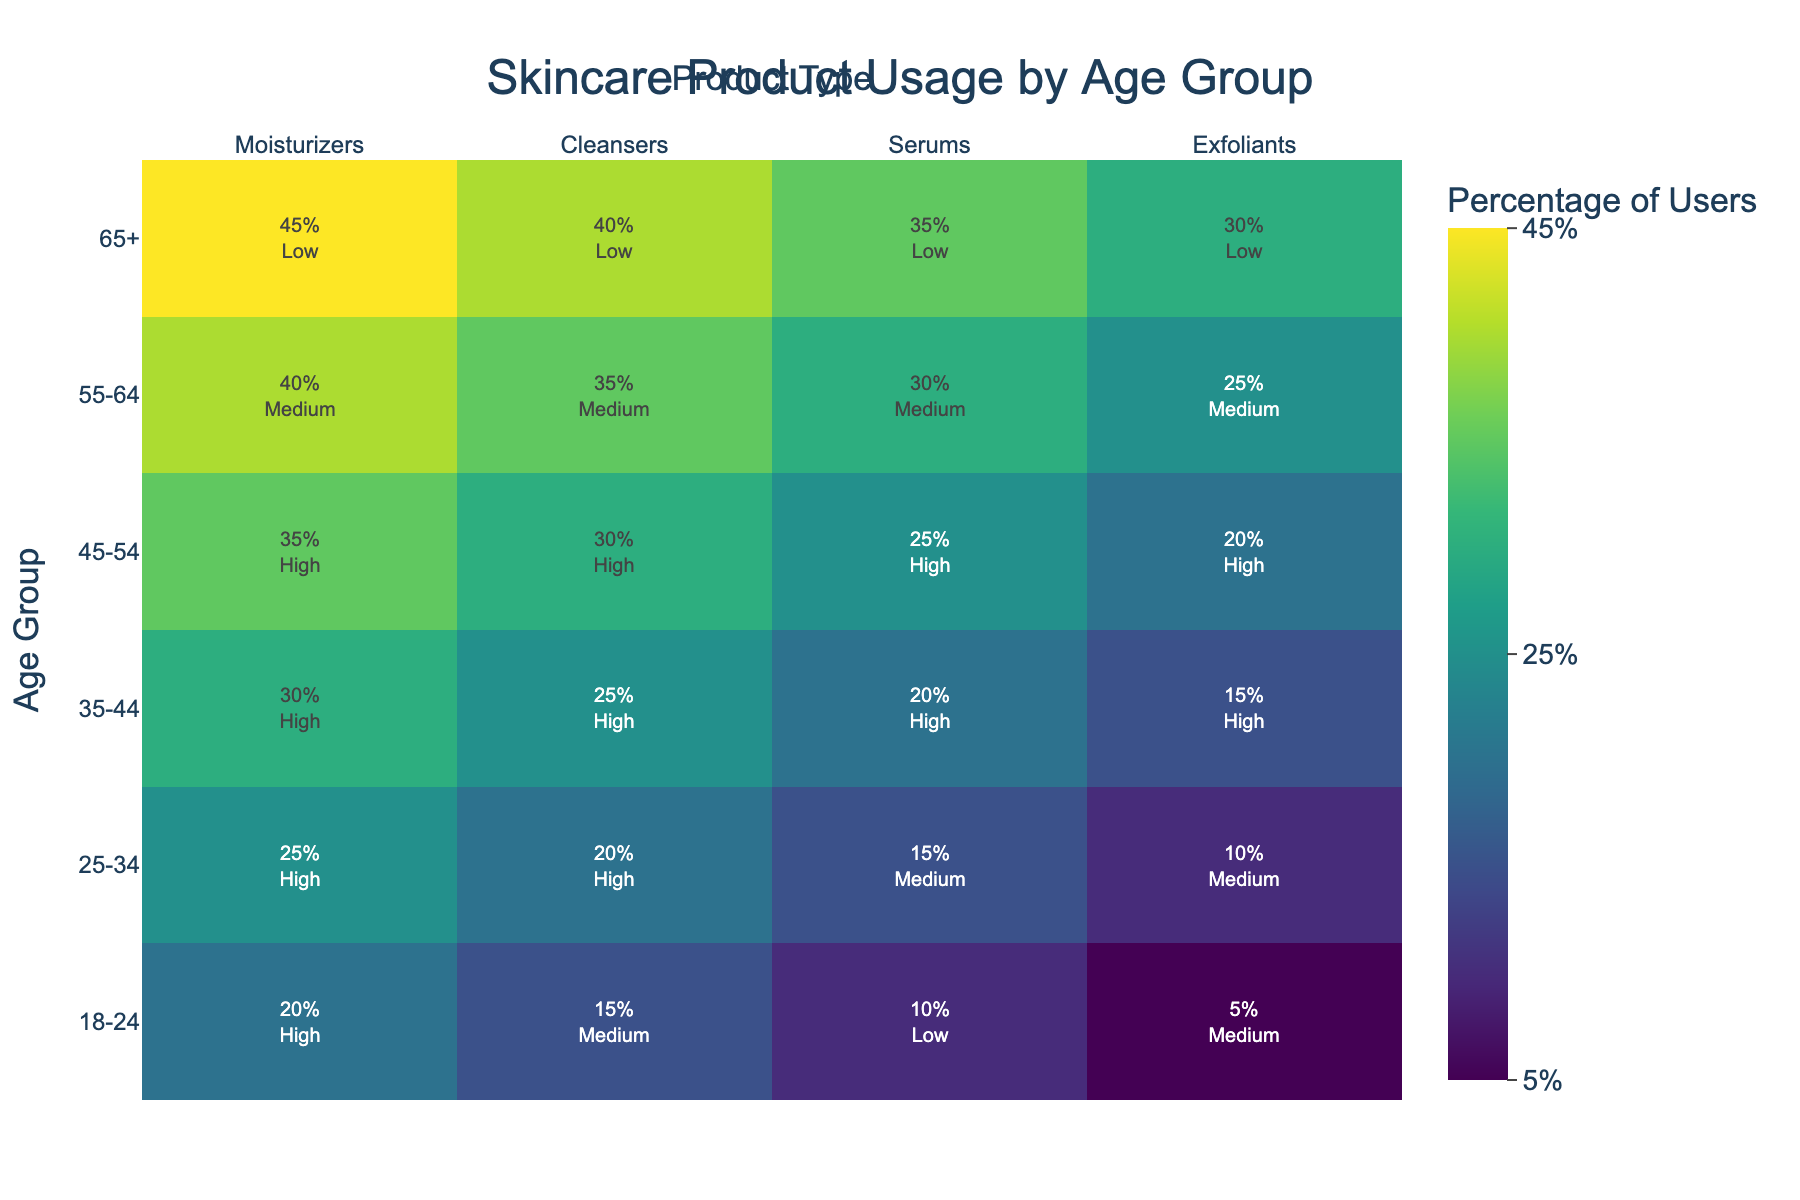What is the title of the heatmap? The title of the heatmap is typically found at the top of the figure. It provides a summary of what the visual represents. By reading the figure, we can identify it.
Answer: Skincare Product Usage by Age Group Which age group has the highest percentage of users for cleansers? Look at the column labeled "Cleansers" and identify the highest value in that column. According to the data provided, the age group with the highest percentage will be marked.
Answer: 65+ What is the purchasing behavior of the age group 35-44 for serums? Locate the row for age group 35-44, then move to the column under "Serums". The purchasing behavior associated with this intersection will be indicated in the figure.
Answer: High How does the percentage of users for exfoliants vary across age groups? Inspect the column related to "Exfoliants" and observe how the percentages change for each age group.
Answer: 5%, 10%, 15%, 20%, 25%, 30% Which product type has the most consistent high purchasing behavior across all age groups? Review each column in the heatmap and identify which product type maintains a high purchasing behavior across the majority of age groups. This involves checking multiple segments of the visual.
Answer: Moisturizers Compare the purchasing behaviors for cleansers between the age groups 18-24 and 55-64. Investigate the cleansers column and find the rows for the age groups 18-24 and 55-64. Compare the purchasing behavior values.
Answer: Medium vs Medium What percentage of users aged 25-34 prefer moisturizers? Locate the row labeled 25-34 and find the value under the "Moisturizers" column. This percentage represents their preference.
Answer: 25% Which age group shows a low purchasing behavior for every product type? Check each row to see which age group consistently shows a low purchasing behavior across all product types. This will typically be the segment with low values for all products.
Answer: 65+ 